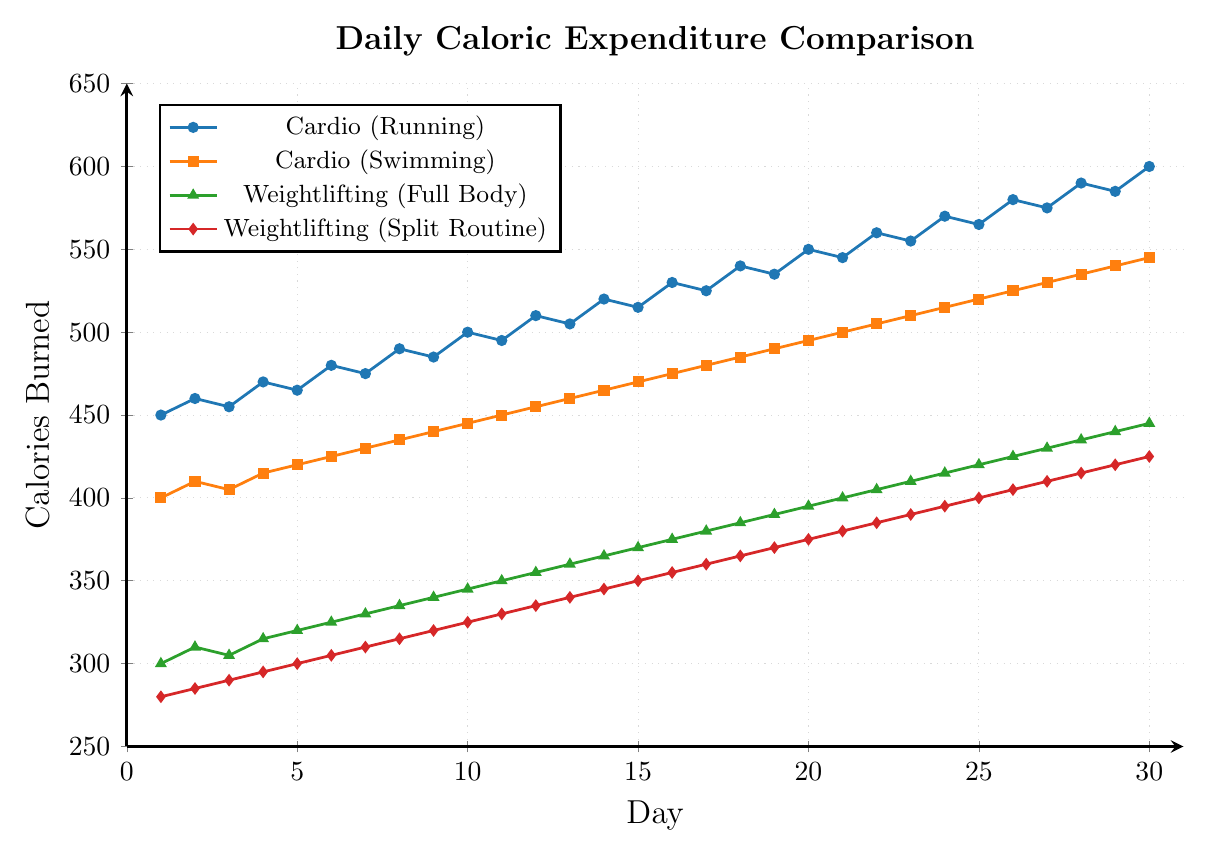How does the caloric expenditure of Cardio (Running) compare to Weightlifting (Full Body) on Day 10? On Day 10, the caloric expenditure for Cardio (Running) is 500 calories, and for Weightlifting (Full Body) it is 345 calories. By comparing these values, Cardio (Running) burns more calories than Weightlifting (Full Body) on Day 10.
Answer: Cardio (Running) burns more calories What is the difference in caloric expenditure between Cardio (Swimming) and Weightlifting (Split Routine) on Day 20? On Day 20, Cardio (Swimming) burns 495 calories and Weightlifting (Split Routine) burns 375 calories. The difference between them is \(495 - 375 = 120\) calories.
Answer: 120 calories Which exercise shows the highest increase in caloric expenditure from Day 1 to Day 30? For each exercise, the increase from Day 1 to Day 30 is as follows:
- Cardio (Running): \(600 - 450 = 150\)
- Cardio (Swimming): \(545 - 400 = 145\)
- Weightlifting (Full Body): \(445 - 300 = 145\)
- Weightlifting (Split Routine): \(425 - 280 = 145\)
Cardio (Running) has the highest increase in caloric expenditure with a 150 calories increase.
Answer: Cardio (Running) What's the average daily caloric expenditure for Weightlifting (Split Routine) over the 30-day period? Sum all the caloric expenditures for Weightlifting (Split Routine) from Day 1 to Day 30: \(280 + 285 + 290 + ... + 420 + 425 = 10,500\) calories. The average is \(10,500 / 30 = 350\) calories per day.
Answer: 350 calories per day Which exercise has the lowest daily caloric expenditure on average over the 30 days? Average daily caloric expenditures over the 30 days for each exercise are:
- Cardio (Running): \(\frac{(450 + 460 + ... + 590 + 600)}{30} = 525\)
- Cardio (Swimming): \(\frac{(400 + 410 + ... + 535 + 545)}{30} = 472.5\)
- Weightlifting (Full Body): \(\frac{(300 + 310 + ... + 435 + 445)}{30} = 372.5\)
- Weightlifting (Split Routine): \(\frac{(280 + 285 + ... + 420 + 425)}{30} = 352.5\)
Weightlifting (Split Routine) has the lowest average daily caloric expenditure.
Answer: Weightlifting (Split Routine) On which day does the caloric expenditure of Cardio (Swimming) first exceed 500 calories? By checking the values for Cardio (Swimming): it first exceeds 500 calories on Day 22 with an expenditure of 505 calories.
Answer: Day 22 What is the median caloric expenditure for Weightlifting (Full Body) over the 30 days? To find the median, list the 30 data points in ascending order and find the middle value. Since there are 30 data points, the median will be the average of the 15th and 16th values. The values for Weightlifting (Full Body) range from 300 to 445, so the median (average of 15th and 16th values: 370, 375) is \( (370 + 375) / 2 = 372.5 \) calories.
Answer: 372.5 calories What is the visual trend of the caloric expenditure for Cardio (Running) over the 30 days? The line representing Cardio (Running) shows a consistent upward trend, indicating that the caloric expenditure increases steadily over the 30-day period.
Answer: Upward trend Compare the caloric expenditures on Day 15 for all exercises. Which exercise burns the most and which the least? On Day 15, the values are:
- Cardio (Running): 515 calories
- Cardio (Swimming): 470 calories
- Weightlifting (Full Body): 370 calories
- Weightlifting (Split Routine): 350 calories
Cardio (Running) burns the most calories and Weightlifting (Split Routine) burns the least.
Answer: Cardio (Running) most, Weightlifting (Split Routine) least 